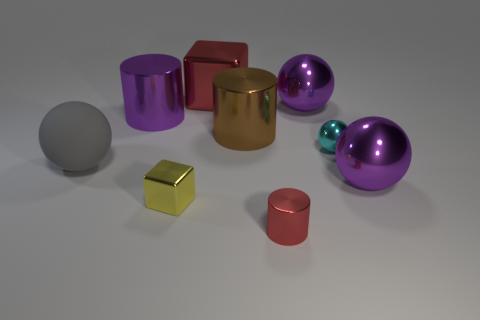There is a matte sphere; are there any red objects behind it?
Give a very brief answer. Yes. There is a thing that is the same color as the small metal cylinder; what is it made of?
Offer a terse response. Metal. How many spheres are small blue objects or tiny red metallic things?
Keep it short and to the point. 0. Is the shape of the brown metal object the same as the small red metal object?
Give a very brief answer. Yes. There is a metal object in front of the small yellow metal block; how big is it?
Provide a succinct answer. Small. Is there a small rubber ball that has the same color as the tiny cylinder?
Make the answer very short. No. Do the metal cube behind the yellow thing and the big brown metal cylinder have the same size?
Make the answer very short. Yes. What is the color of the rubber ball?
Provide a succinct answer. Gray. There is a big ball that is left of the red metal object in front of the large rubber ball; what is its color?
Provide a succinct answer. Gray. Is there a tiny cylinder that has the same material as the small cyan sphere?
Ensure brevity in your answer.  Yes. 